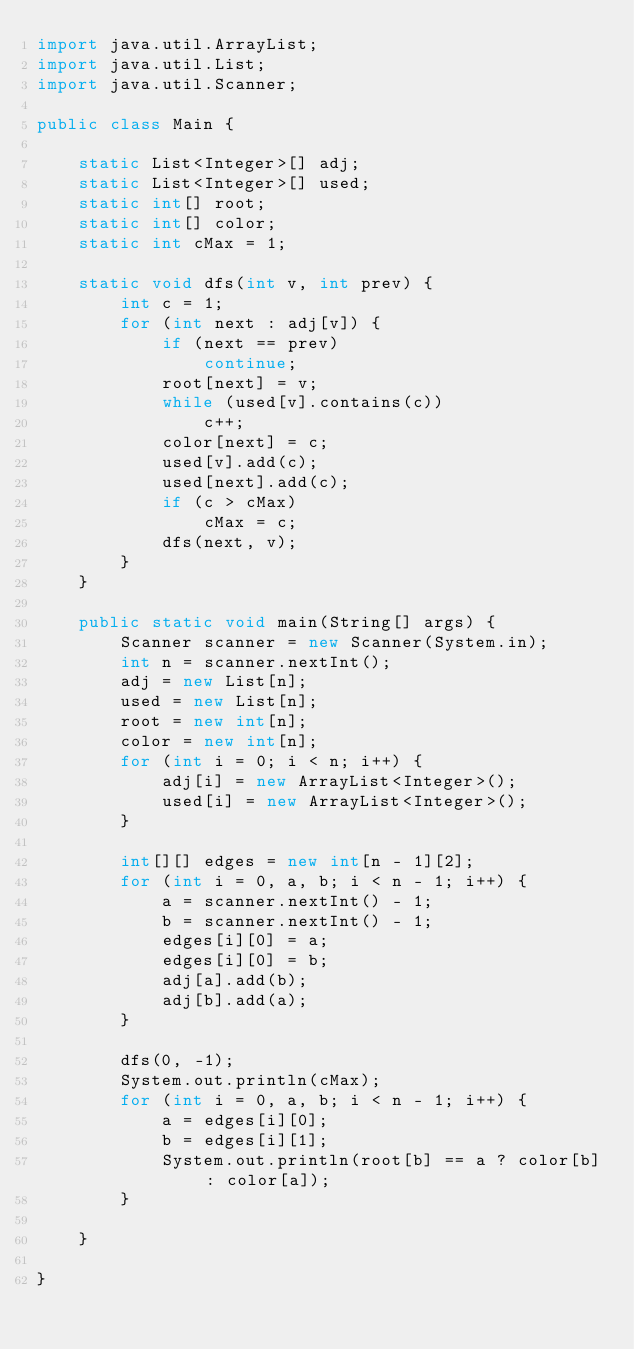<code> <loc_0><loc_0><loc_500><loc_500><_Java_>import java.util.ArrayList;
import java.util.List;
import java.util.Scanner;

public class Main {

	static List<Integer>[] adj;
	static List<Integer>[] used;
	static int[] root;
	static int[] color;
	static int cMax = 1;

	static void dfs(int v, int prev) {
		int c = 1;
		for (int next : adj[v]) {
			if (next == prev)
				continue;
			root[next] = v;
			while (used[v].contains(c))
				c++;
			color[next] = c;
			used[v].add(c);
			used[next].add(c);
			if (c > cMax)
				cMax = c;
			dfs(next, v);
		}
	}

	public static void main(String[] args) {
		Scanner scanner = new Scanner(System.in);
		int n = scanner.nextInt();
		adj = new List[n];
		used = new List[n];
		root = new int[n];
		color = new int[n];
		for (int i = 0; i < n; i++) {
			adj[i] = new ArrayList<Integer>();
			used[i] = new ArrayList<Integer>();
		}

		int[][] edges = new int[n - 1][2];
		for (int i = 0, a, b; i < n - 1; i++) {
			a = scanner.nextInt() - 1;
			b = scanner.nextInt() - 1;
			edges[i][0] = a;
			edges[i][0] = b;
			adj[a].add(b);
			adj[b].add(a);
		}

		dfs(0, -1);
		System.out.println(cMax);
		for (int i = 0, a, b; i < n - 1; i++) {
			a = edges[i][0];
			b = edges[i][1];
			System.out.println(root[b] == a ? color[b] : color[a]);
		}

	}

}
</code> 